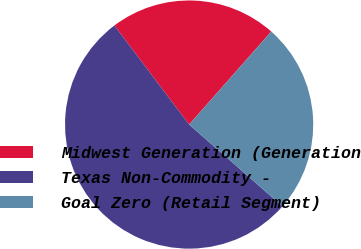Convert chart to OTSL. <chart><loc_0><loc_0><loc_500><loc_500><pie_chart><fcel>Midwest Generation (Generation<fcel>Texas Non-Commodity -<fcel>Goal Zero (Retail Segment)<nl><fcel>21.8%<fcel>53.26%<fcel>24.94%<nl></chart> 